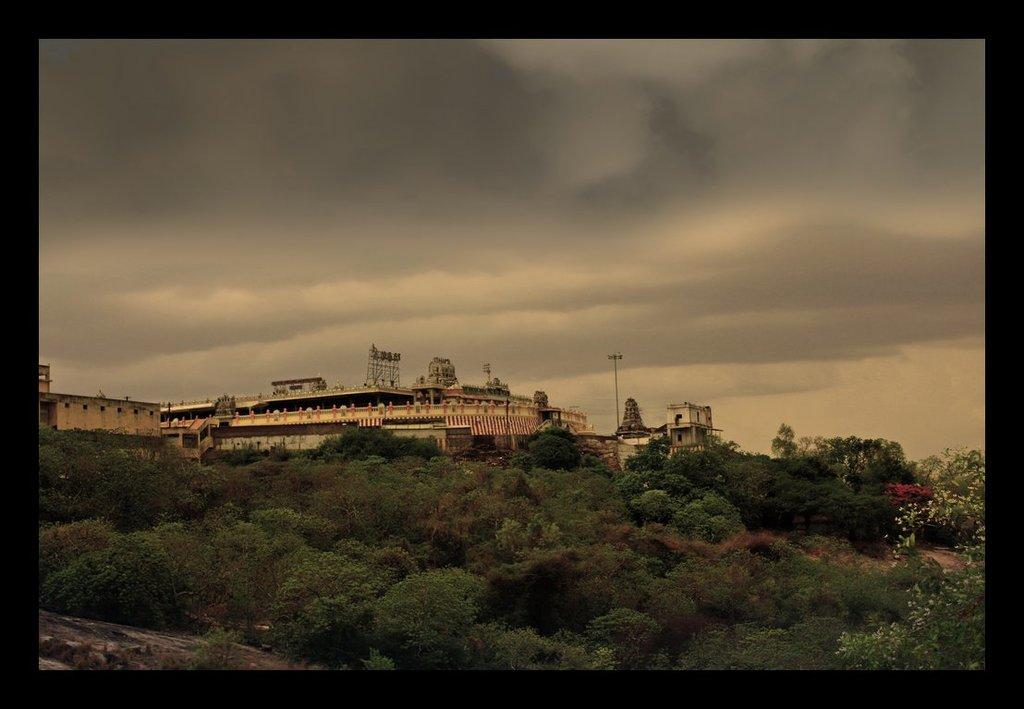What is the main structure in the center of the image? There is a temple in the center of the image. What type of natural vegetation can be seen in the image? There are trees in the image. What is visible in the background of the image? The sky is visible in the background of the image. Are there any weather conditions depicted in the image? Yes, clouds are present in the background of the image. What type of wool is being used to create the temple's roof in the image? There is no wool present in the image, and the temple's roof is not made of wool. 